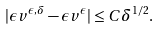Convert formula to latex. <formula><loc_0><loc_0><loc_500><loc_500>| { \epsilon } v ^ { \epsilon , \delta } - { \epsilon } v ^ { \epsilon } | \leq C { \delta } ^ { 1 / 2 } .</formula> 